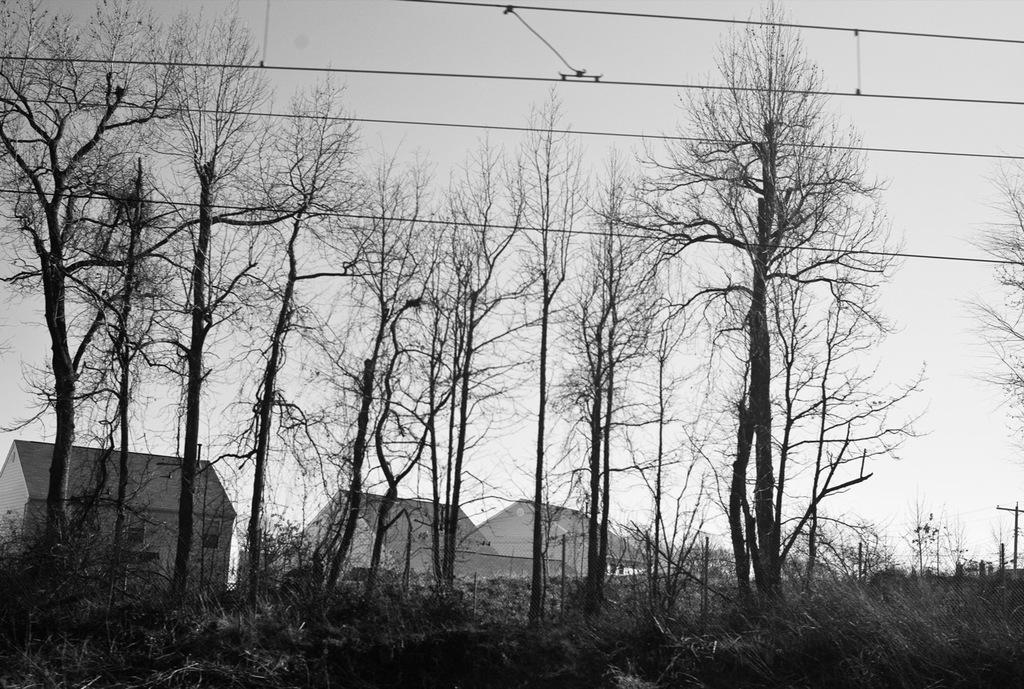What is the color scheme of the image? The image is black and white. What type of vegetation can be seen in the image? There is a group of trees and plants in the image. What type of structures are present in the image? There are houses with roofs in the image. What other objects can be seen in the image? There are poles and wires in the image. What is visible in the background of the image? The sky is visible in the image, and it appears cloudy. How many lizards can be seen climbing the trees in the image? There are no lizards present in the image; it features a group of trees and plants. What type of wave can be seen crashing on the shore in the image? There is no shore or wave present in the image; it is a black and white image of trees, plants, houses, poles, wires, and a cloudy sky. 